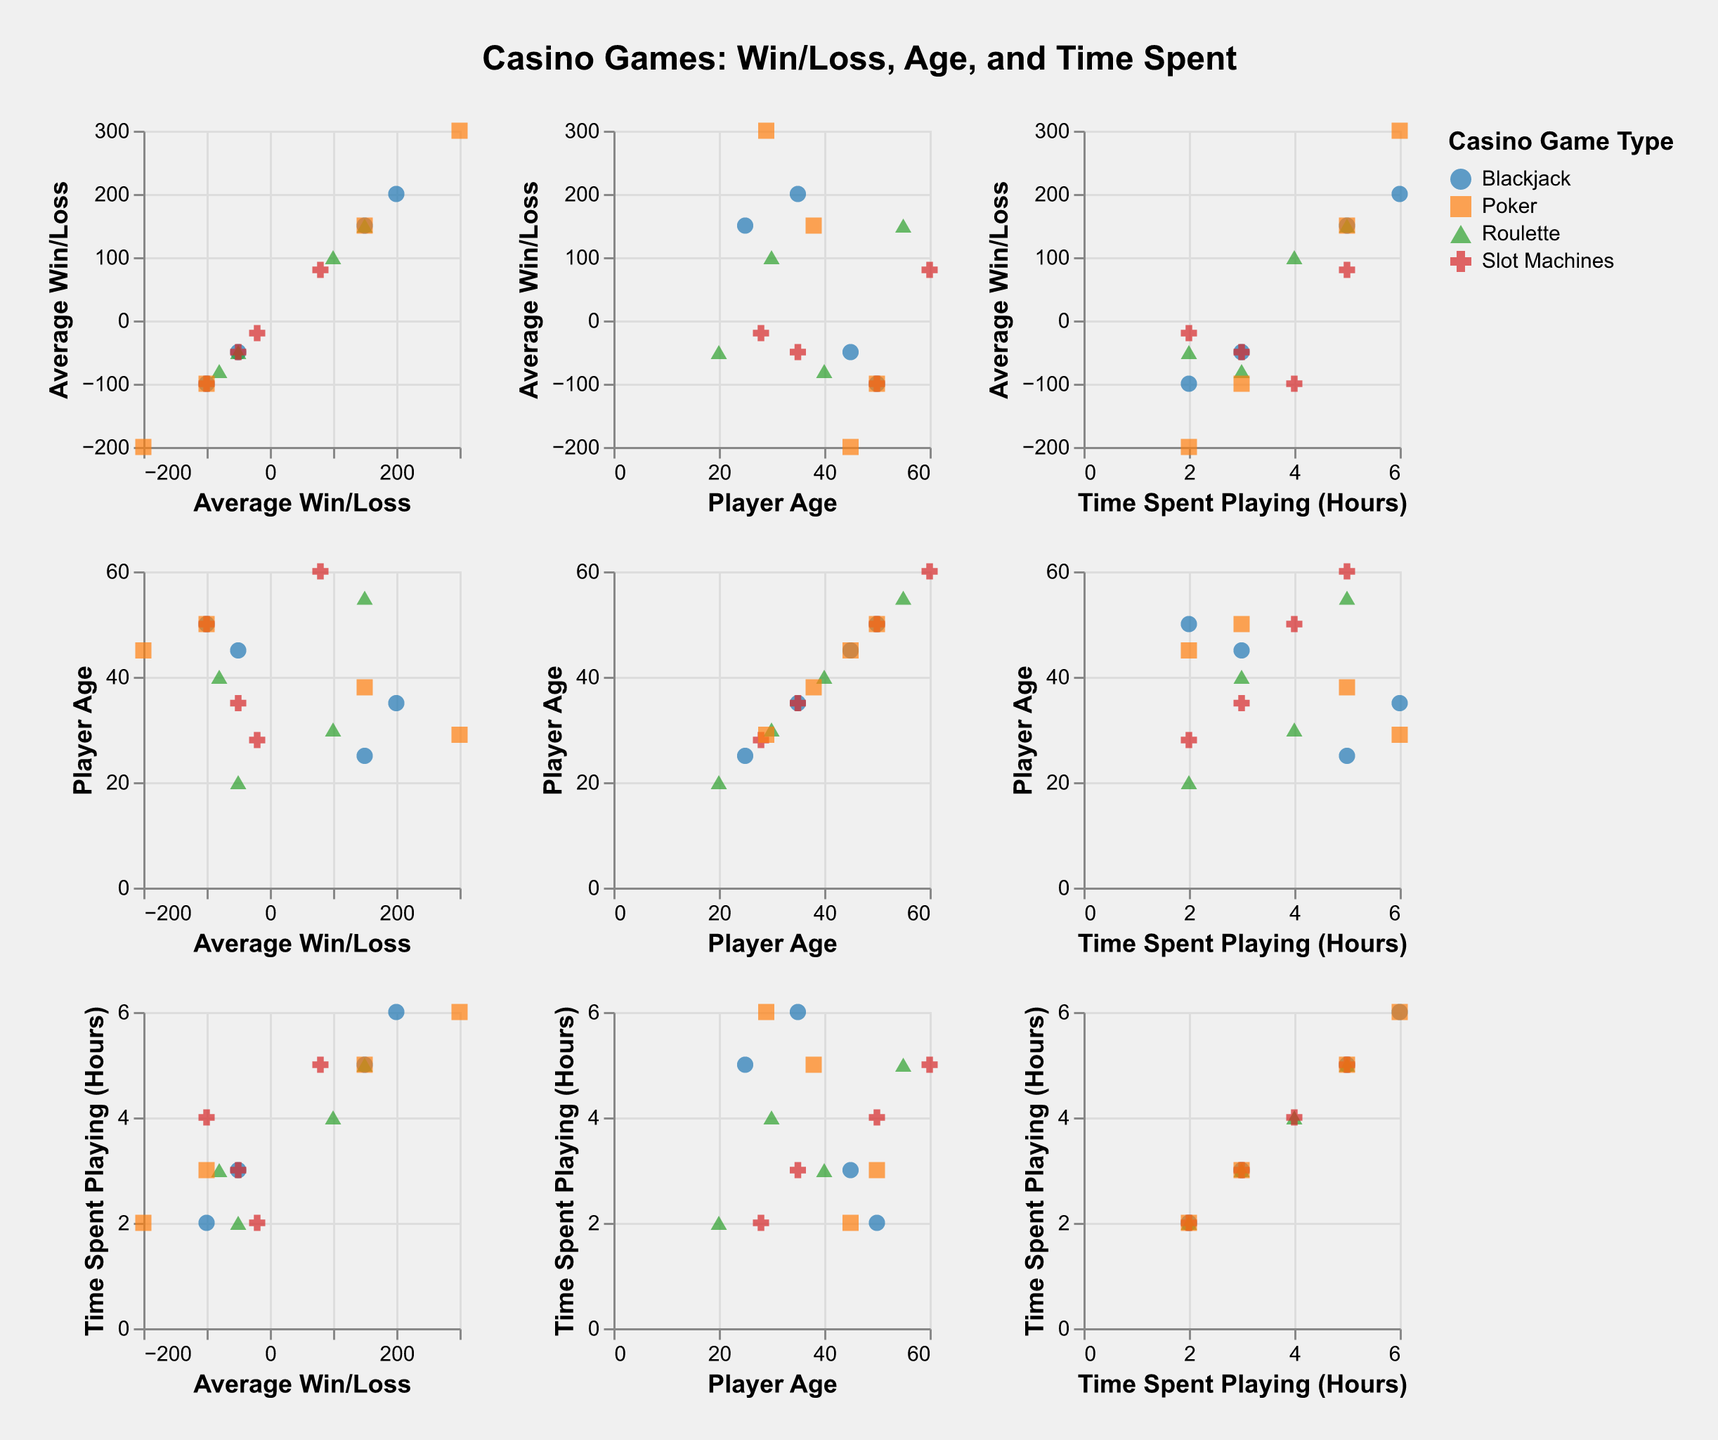How many data points are in the Blackjack category? To find the number of data points for Blackjack, count all the points that are colored the same and have the same shape, specifically for Blackjack.
Answer: 4 What's the average age of players who played Blackjack? For Blackjack, the ages are 25, 45, 35, and 50. Add these together (25 + 45 + 35 + 50 = 155) and divide by the number of players (4). The average is 155 / 4 = 38.75.
Answer: 38.75 Is there a relationship between average win/loss and time spent playing for players of Slot Machines? To answer this, look at the points for Slot Machines (same color and shape) in the average win/loss vs. time spent playing section. Check if there seems to be a pattern or trend in the direction or clustering of points.
Answer: Points are scattered, suggesting no strong relationship Which game type has the highest average win/loss? Identify the game type with the highest y-value in the columns representing Average Win/Loss. The highest point corresponds to Poker with a win of 300.
Answer: Poker What is the relationship between time spent playing and player age for Roulette players? Look at the points for Roulette (same color and shape) in the player age vs. time spent playing section. Check if there are any visible trends such as increasing, decreasing, or a cluster pattern.
Answer: Older players tend to spend more time Which game type has the most negative average win/loss? Identify the game type with the lowest point in the Average Win/Loss column. The lowest value corresponds to Poker with a loss of -200.
Answer: Poker Do younger or older players tend to spend more time playing Poker? Look at the points for Poker (same color and shape) in the player age vs. time spent playing section. Compare the ages and corresponding times.
Answer: Younger players tend to spend more time How many data points have an average win/loss below zero? Count all the points whose y-value is below zero in the Average Win/Loss column, irrespective of game type.
Answer: 7 What's the total sum of times spent playing for Blackjack players? Add up the time values for Blackjack players: 5 + 3 + 6 + 2 = 16 hours.
Answer: 16 hours Which game type appears to have the most consistent average win/loss range? Examine the variation of points along the average win/loss axis for each game type. Consistency implies less spread along this axis. Slot Machines tend to have a smaller range.
Answer: Slot Machines 